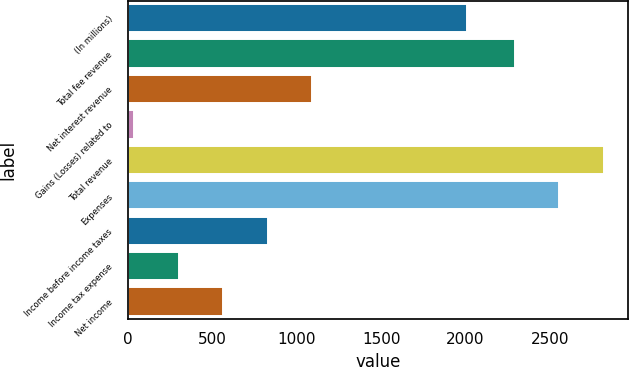Convert chart to OTSL. <chart><loc_0><loc_0><loc_500><loc_500><bar_chart><fcel>(In millions)<fcel>Total fee revenue<fcel>Net interest revenue<fcel>Gains (Losses) related to<fcel>Total revenue<fcel>Expenses<fcel>Income before income taxes<fcel>Income tax expense<fcel>Net income<nl><fcel>2009<fcel>2291<fcel>1092.6<fcel>37<fcel>2818.8<fcel>2554.9<fcel>828.7<fcel>300.9<fcel>564.8<nl></chart> 